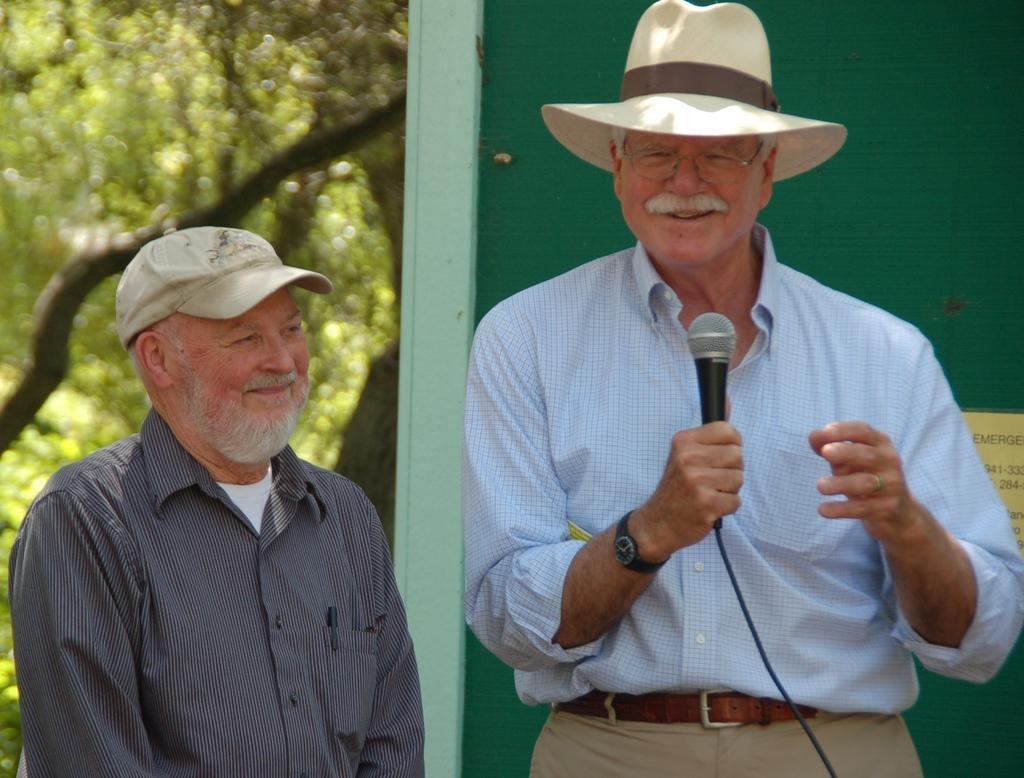Could you give a brief overview of what you see in this image? On the right there is a man who is wearing hat, spectacles, shirt, watch and trouser. He is holding a mic. Beside him we can see other man who is wearing cap and shirt. Here we can see a pen. On the right back we can see green color shade. On the left background we can see many trees. 